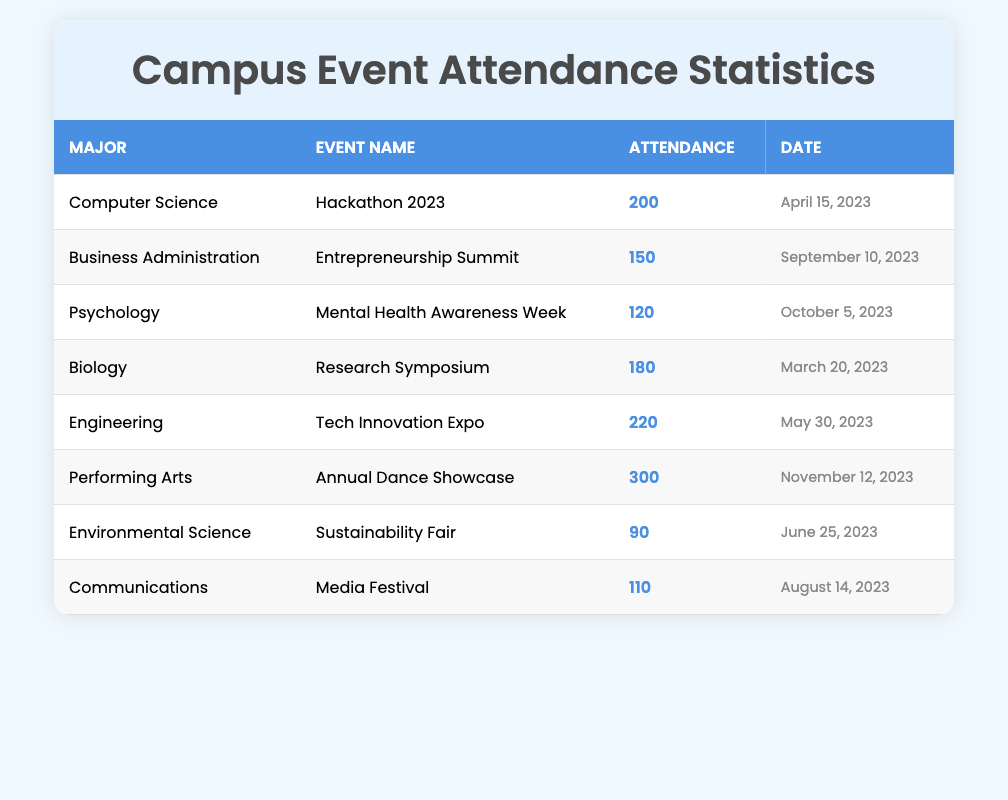What was the attendance for the "Hackathon 2023"? The attendance for the "Hackathon 2023" is mentioned in the row associated with Computer Science, which shows an attendance of 200.
Answer: 200 Which event had the highest attendance? The "Annual Dance Showcase" under the Performing Arts major had the highest attendance, recorded at 300.
Answer: 300 How many attendees were present at events related to Environmental Science? The only event listed for Environmental Science is the "Sustainability Fair," which had an attendance of 90. Thus, the total attendance for this major is 90.
Answer: 90 What is the total attendance for all Engineering-related events? The only event listed for Engineering is the "Tech Innovation Expo," which had an attendance of 220. Thus, the total attendance for this major is also 220.
Answer: 220 Was there any event in the table with an attendance of less than 100? The "Sustainability Fair" under Environmental Science had an attendance of 90, which is less than 100. Therefore, the answer is yes.
Answer: Yes Which major had an attendance of more than 150 but less than 200? The Psychology major participated in "Mental Health Awareness Week" with an attendance of 120, and Business Administration's "Entrepreneurship Summit" had 150. When looking for attendance between 150 and 200, we find that there are no majors that fit this criteria.
Answer: No If we consider the total attendance across all events, what is the average attendance? To find the average attendance, we first sum all attendances: 200 + 150 + 120 + 180 + 220 + 300 + 90 + 110 = 1,370. There are 8 events, so the average attendance is 1,370 divided by 8, which gives 171.25.
Answer: 171.25 How many events were attended by more than 100 students? By analyzing each attendance figure in the table, we find that the events with attendance above 100 are "Hackathon 2023" (200), "Entrepreneurship Summit" (150), "Mental Health Awareness Week" (120), "Research Symposium" (180), "Tech Innovation Expo" (220), "Annual Dance Showcase" (300), and "Media Festival" (110). This totals 7 events.
Answer: 7 Is there any event listed for Psychology? Yes, the "Mental Health Awareness Week" is listed for the Psychology major with an attendance of 120.
Answer: Yes 